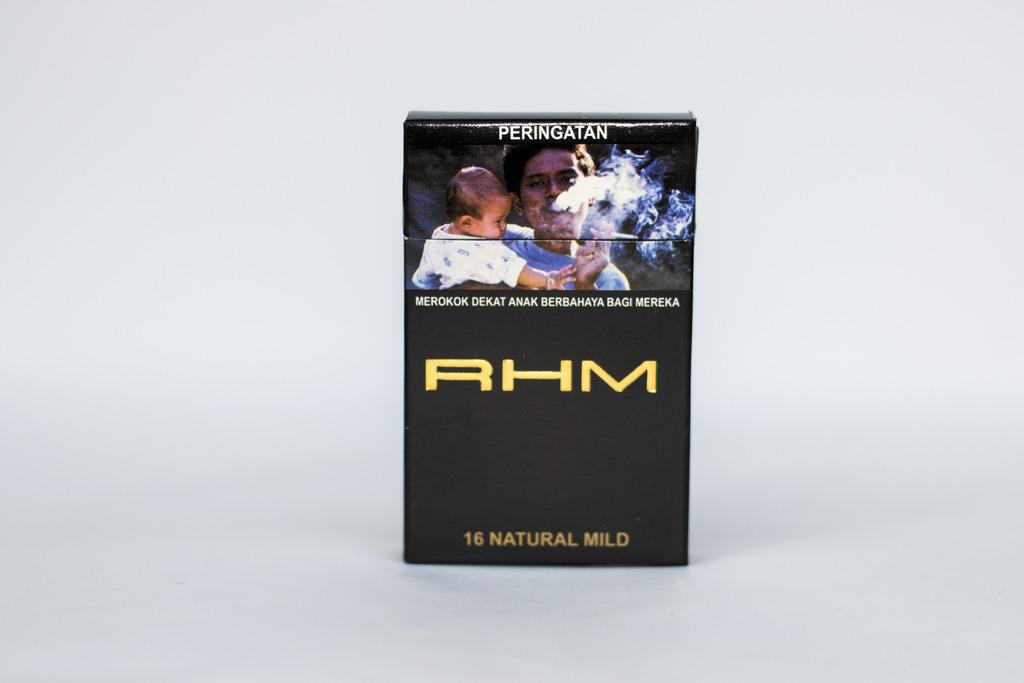What is the color of the box in the image? The box in the image is black. How many people are present in the image? There are two people in the image. What is written on the box? There is writing on the box. What is the color of the background in the image? The background of the image is white. Are there any toys visible in the image? No, there are no toys present in the image. Is the box being used to cover something in the image? There is no indication in the image that the box is being used to cover anything. 